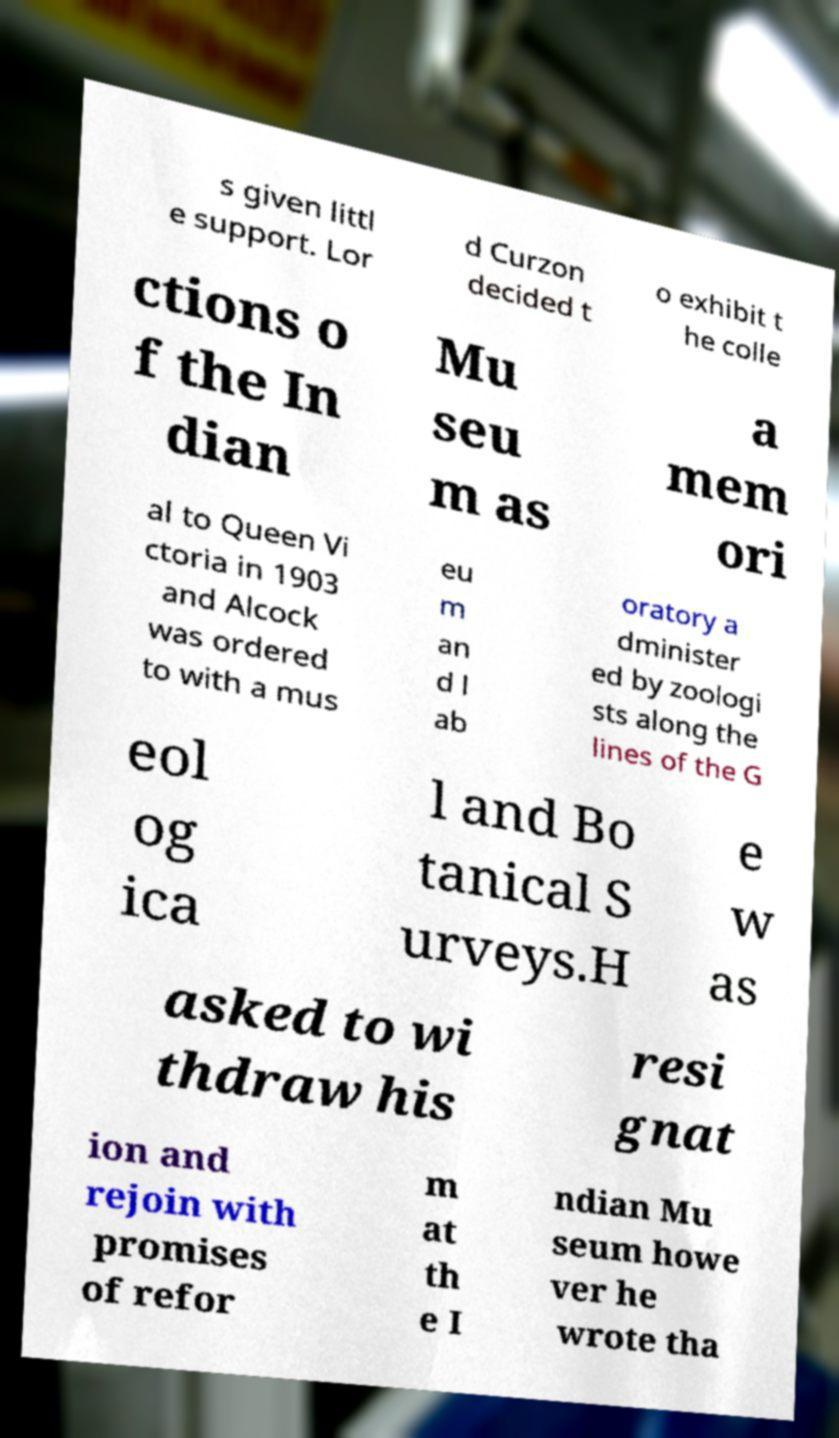Can you accurately transcribe the text from the provided image for me? s given littl e support. Lor d Curzon decided t o exhibit t he colle ctions o f the In dian Mu seu m as a mem ori al to Queen Vi ctoria in 1903 and Alcock was ordered to with a mus eu m an d l ab oratory a dminister ed by zoologi sts along the lines of the G eol og ica l and Bo tanical S urveys.H e w as asked to wi thdraw his resi gnat ion and rejoin with promises of refor m at th e I ndian Mu seum howe ver he wrote tha 